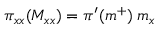<formula> <loc_0><loc_0><loc_500><loc_500>\pi _ { x x } ( M _ { x x } ) = \pi ^ { \prime } ( m ^ { + } ) \, m _ { x }</formula> 